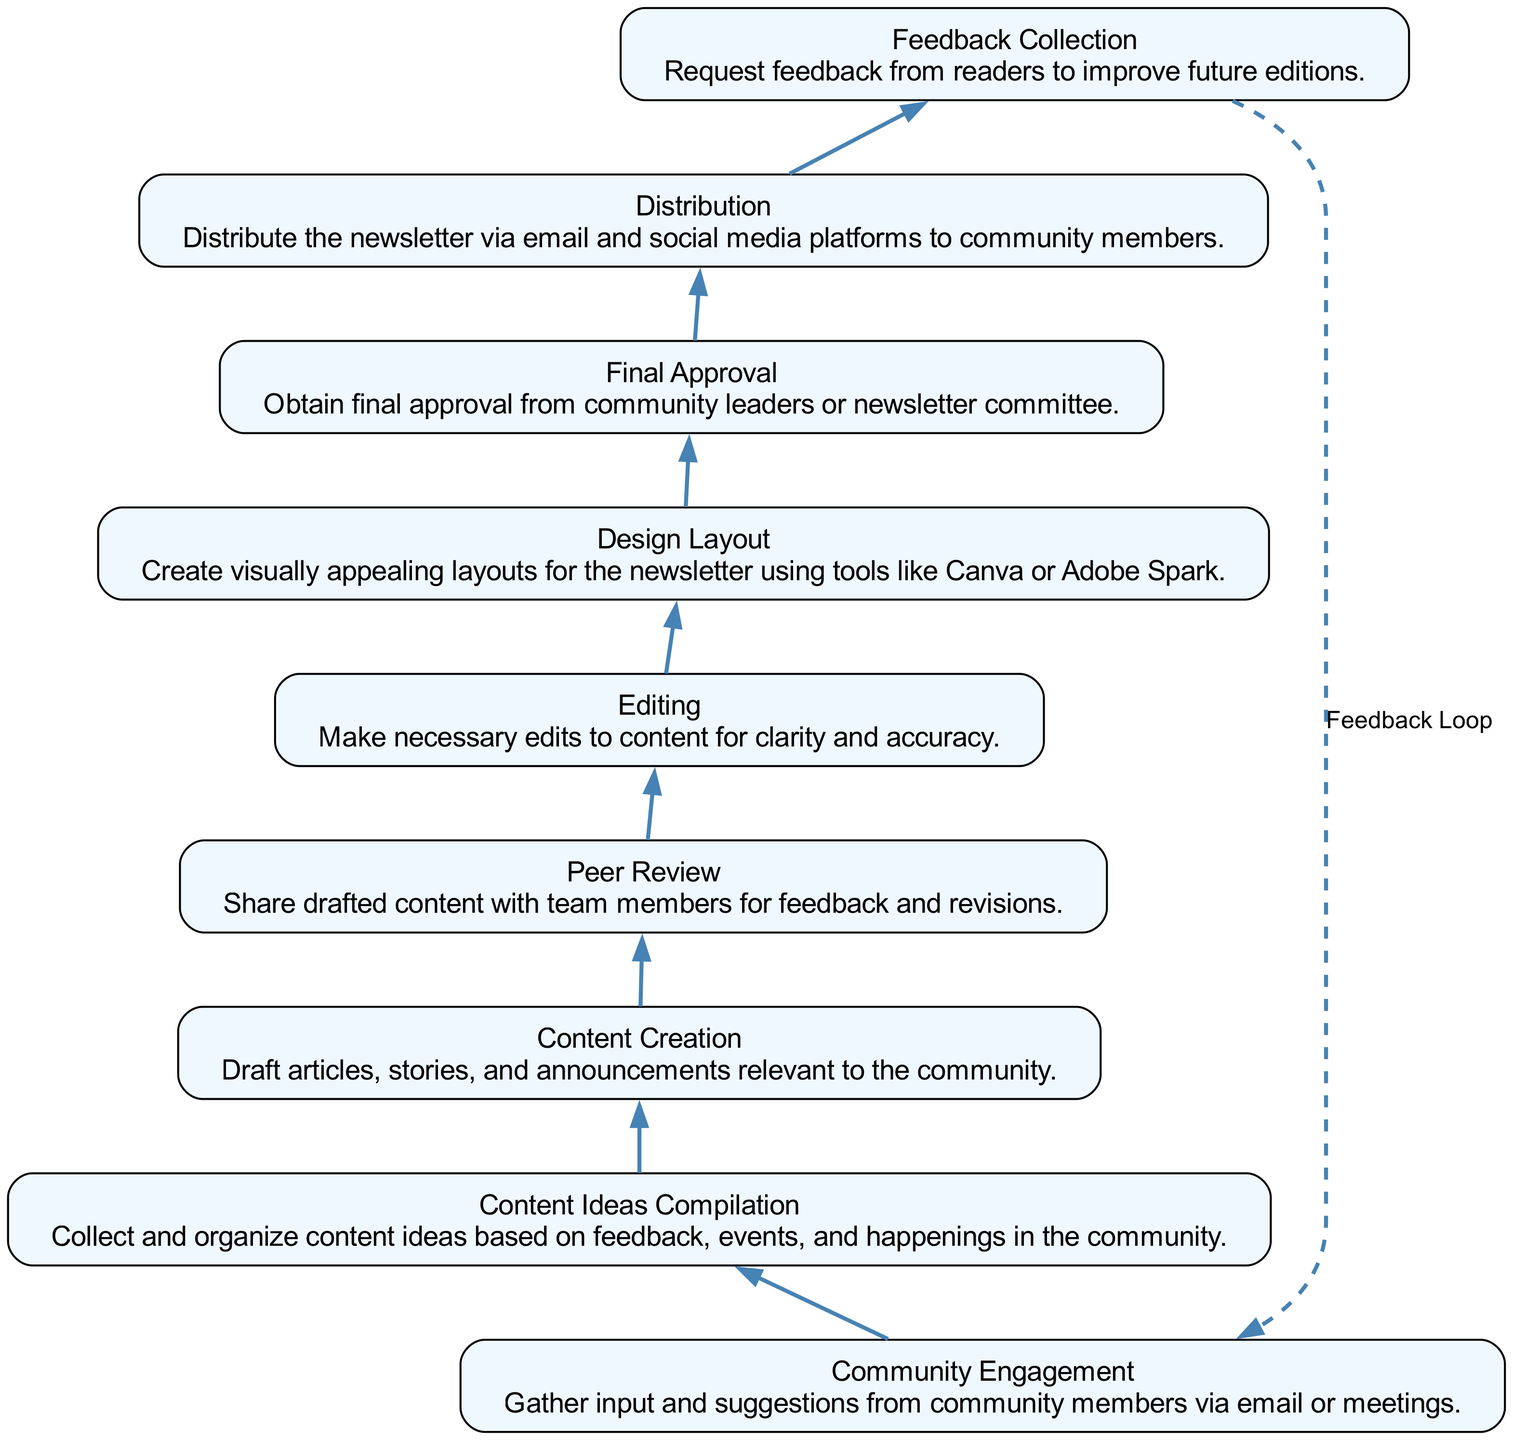What is the first step in the workflow? The first step is identified as "Community Engagement." This is the starting point of the workflow diagram, depicted at the bottom of the chart.
Answer: Community Engagement How many steps are there in total? To answer this, we can simply count the number of nodes (elements) listed in the data provided, which are nine in total.
Answer: 9 What comes directly after "Content Ideas Compilation"? Following the node representing "Content Ideas Compilation," the next step in the diagram is labeled as "Content Creation." This indicates the immediate process that follows in the workflow.
Answer: Content Creation Which node represents the final approval stage? The node that denotes the final approval stage is "Final Approval." This is crucial as it confirms that the content meets community standards before distribution.
Answer: Final Approval What is the feedback loop in the workflow? The feedback loop is indicated by the dashed line connecting the "Feedback Collection" node back to "Community Engagement." This shows that feedback is collected for potential future improvements and suggestions for the next content cycle.
Answer: Feedback Loop What type of content is created in the "Content Creation" step? In the "Content Creation" step, the type of content includes "draft articles, stories, and announcements relevant to the community." This portrays what is to be produced in this part of the workflow.
Answer: Draft articles, stories, and announcements What is obtained during the "Final Approval" stage? During the "Final Approval" stage, the workflow specifies that final approval from "community leaders or newsletter committee" is obtained. This emphasizes the importance of validating the content before it is distributed.
Answer: Final approval from community leaders or newsletter committee Which steps are involved in reviewing the content? The steps involved in reviewing the content include "Peer Review" and "Editing." First, team members provide feedback, after which the necessary edits are made for clarity and accuracy.
Answer: Peer Review and Editing How is the newsletter distributed? The distribution of the newsletter occurs via email and social media platforms, as articulated in the "Distribution" step. This detail reveals the channels used to reach the community members effectively.
Answer: Via email and social media platforms 